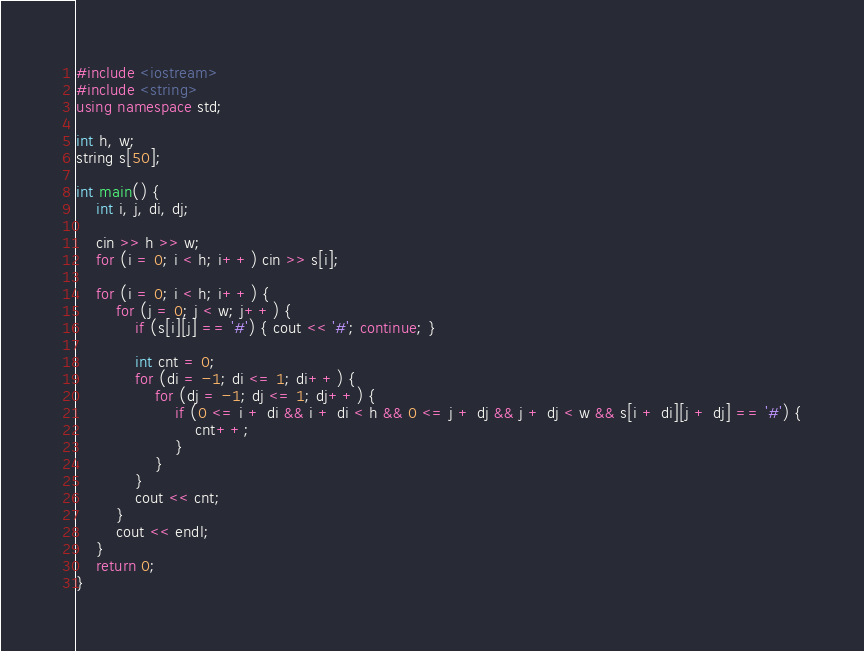<code> <loc_0><loc_0><loc_500><loc_500><_C++_>#include <iostream>
#include <string>
using namespace std;

int h, w;
string s[50];

int main() {
	int i, j, di, dj;
	
	cin >> h >> w;
	for (i = 0; i < h; i++) cin >> s[i];
	
	for (i = 0; i < h; i++) {
		for (j = 0; j < w; j++) {
			if (s[i][j] == '#') { cout << '#'; continue; }
			
			int cnt = 0;
			for (di = -1; di <= 1; di++) {
				for (dj = -1; dj <= 1; dj++) {
					if (0 <= i + di && i + di < h && 0 <= j + dj && j + dj < w && s[i + di][j + dj] == '#') {
						cnt++;
					}
				}
			}
			cout << cnt;
		}
		cout << endl;
	}
	return 0;
}</code> 